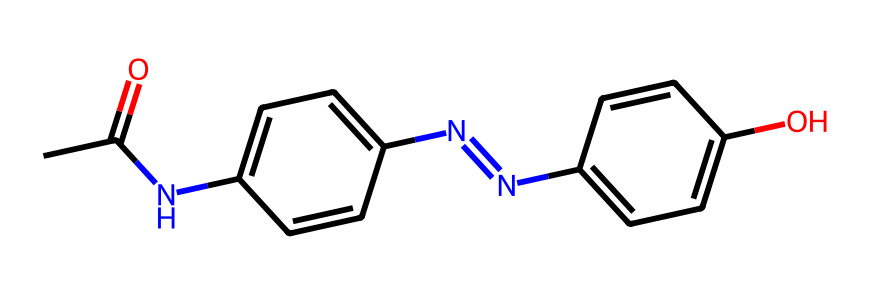What is the molecular formula of this compound? To determine the molecular formula, count each type of atom in the SMILES representation. For this compound, we have 15 carbon atoms, 14 hydrogen atoms, 4 nitrogen atoms, and 3 oxygen atoms. So, the combined molecular formula is C15H14N4O3.
Answer: C15H14N4O3 How many nitrogen atoms are present? By looking at the SMILES representation, we can identify the nitrogen atoms, which are represented by 'N'. Counting reveals there are 4 nitrogen atoms in total in the structure.
Answer: 4 What type of bonding is primarily observed in this structure? The structure includes multiple aromatic rings and functional groups that suggest the presence of covalent bonds, which are dominant in organic compounds. Since the compound has both single and double bonds, this is primarily a covalent compound.
Answer: covalent Does this compound have any functional groups? Analyzing the SMILES reveals that it contains an amide group (-C(=O)N-), azobenzene (-N=N-), and a phenolic hydroxyl group (-OH), which confirms that it has several functional groups.
Answer: yes How many rings are present in the structure? By inspecting the structure derived from the SMILES, we can see that it contains two aromatic rings from the azobenzene part. Hence, the total number of rings present is 2.
Answer: 2 What role does the azo group play in light sensitivity? The azo group (-N=N-) is known for its ability to undergo cis-trans isomerization when exposed to light, which is a key feature that allows the dynamic behavior in response to light stimuli.
Answer: isomerization 